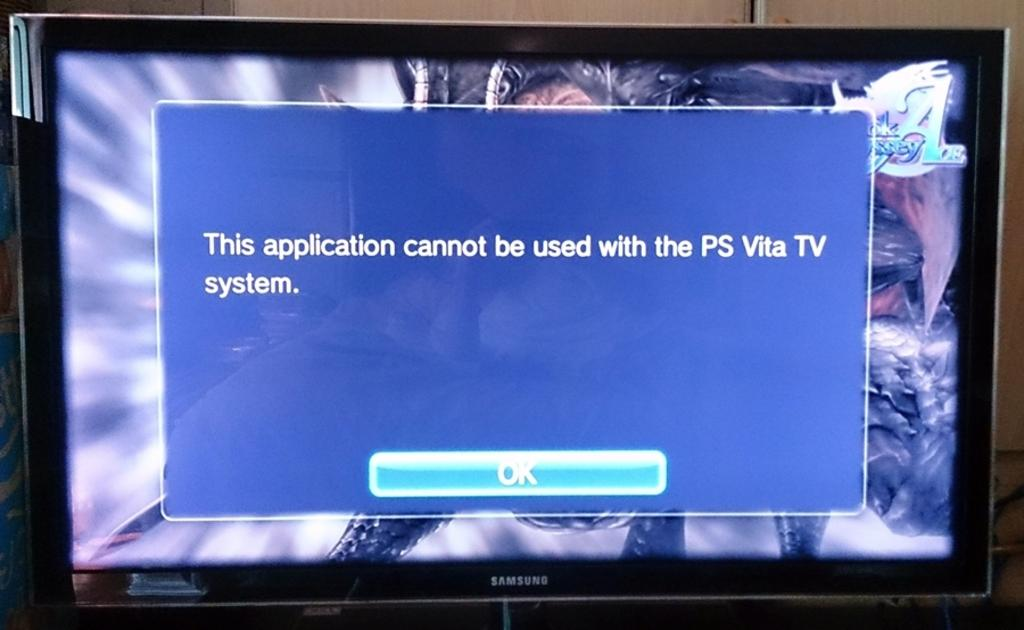<image>
Summarize the visual content of the image. an error on the tv reading : application cannot be used with the PS Vita TV system. 